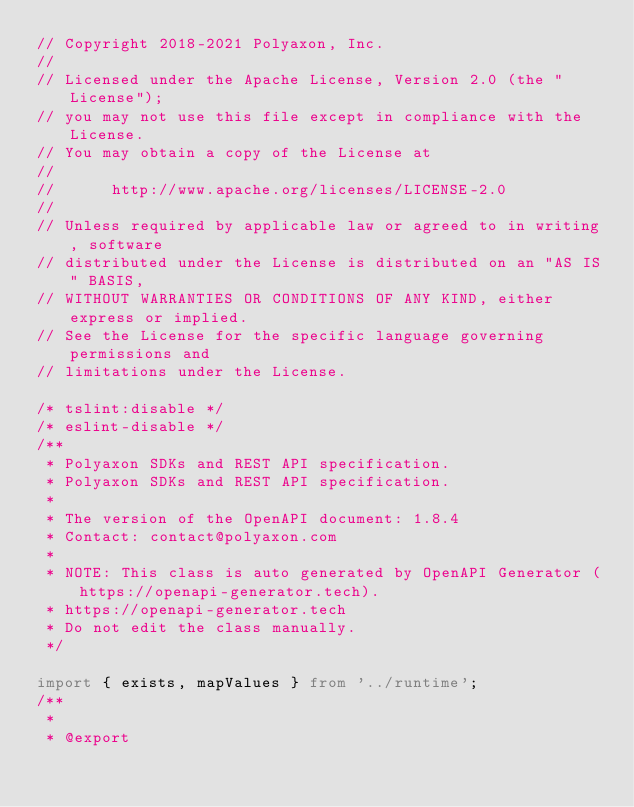Convert code to text. <code><loc_0><loc_0><loc_500><loc_500><_TypeScript_>// Copyright 2018-2021 Polyaxon, Inc.
//
// Licensed under the Apache License, Version 2.0 (the "License");
// you may not use this file except in compliance with the License.
// You may obtain a copy of the License at
//
//      http://www.apache.org/licenses/LICENSE-2.0
//
// Unless required by applicable law or agreed to in writing, software
// distributed under the License is distributed on an "AS IS" BASIS,
// WITHOUT WARRANTIES OR CONDITIONS OF ANY KIND, either express or implied.
// See the License for the specific language governing permissions and
// limitations under the License.

/* tslint:disable */
/* eslint-disable */
/**
 * Polyaxon SDKs and REST API specification.
 * Polyaxon SDKs and REST API specification.
 *
 * The version of the OpenAPI document: 1.8.4
 * Contact: contact@polyaxon.com
 *
 * NOTE: This class is auto generated by OpenAPI Generator (https://openapi-generator.tech).
 * https://openapi-generator.tech
 * Do not edit the class manually.
 */

import { exists, mapValues } from '../runtime';
/**
 * 
 * @export</code> 